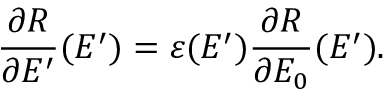Convert formula to latex. <formula><loc_0><loc_0><loc_500><loc_500>{ \frac { \partial R } { \partial E ^ { \prime } } ( E ^ { \prime } ) } = \varepsilon ( E ^ { \prime } ) { \frac { \partial R } { \partial E _ { 0 } } ( E ^ { \prime } ) } .</formula> 